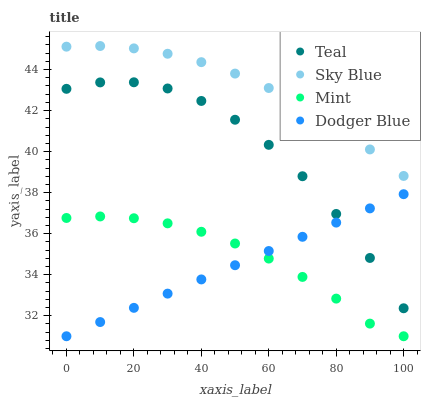Does Dodger Blue have the minimum area under the curve?
Answer yes or no. Yes. Does Sky Blue have the maximum area under the curve?
Answer yes or no. Yes. Does Mint have the minimum area under the curve?
Answer yes or no. No. Does Mint have the maximum area under the curve?
Answer yes or no. No. Is Dodger Blue the smoothest?
Answer yes or no. Yes. Is Teal the roughest?
Answer yes or no. Yes. Is Mint the smoothest?
Answer yes or no. No. Is Mint the roughest?
Answer yes or no. No. Does Mint have the lowest value?
Answer yes or no. Yes. Does Teal have the lowest value?
Answer yes or no. No. Does Sky Blue have the highest value?
Answer yes or no. Yes. Does Teal have the highest value?
Answer yes or no. No. Is Dodger Blue less than Sky Blue?
Answer yes or no. Yes. Is Sky Blue greater than Teal?
Answer yes or no. Yes. Does Dodger Blue intersect Mint?
Answer yes or no. Yes. Is Dodger Blue less than Mint?
Answer yes or no. No. Is Dodger Blue greater than Mint?
Answer yes or no. No. Does Dodger Blue intersect Sky Blue?
Answer yes or no. No. 